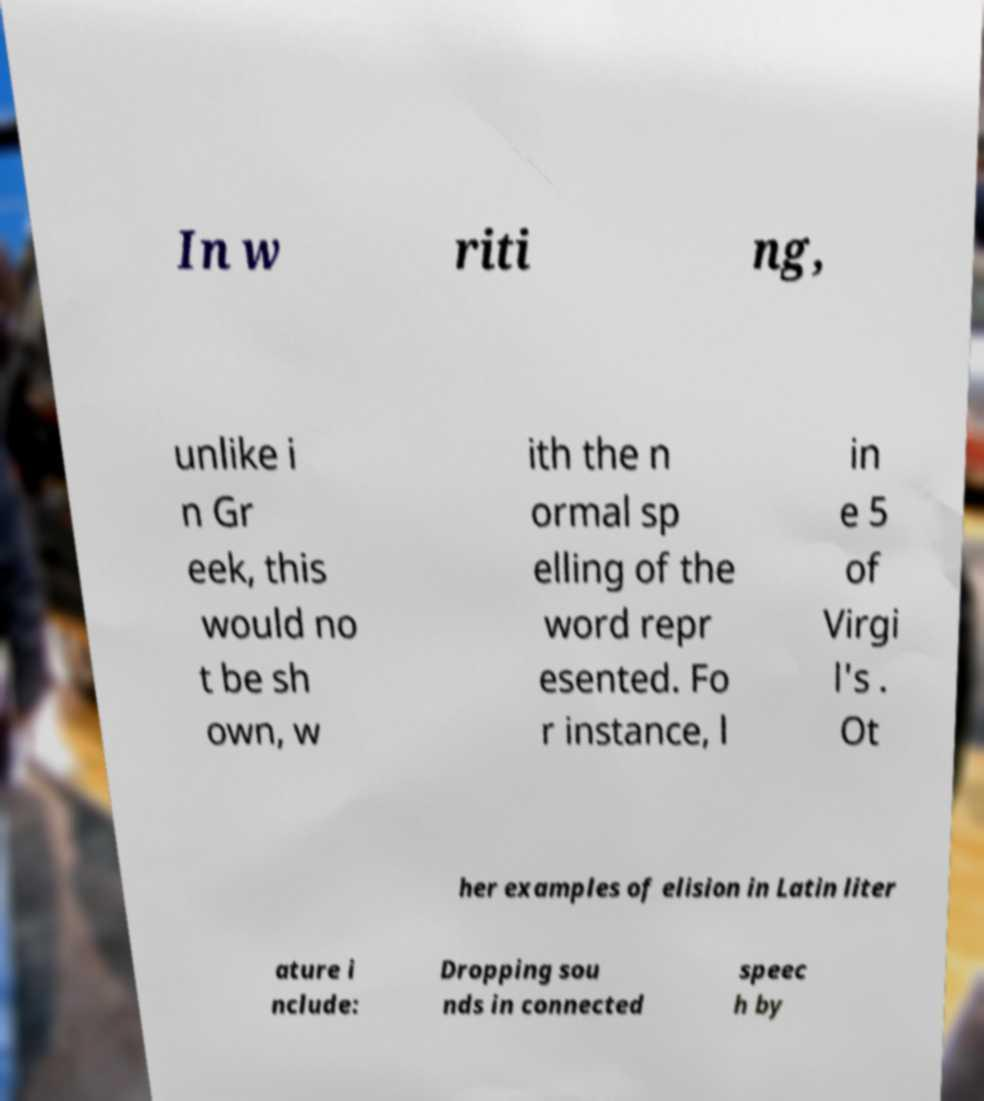For documentation purposes, I need the text within this image transcribed. Could you provide that? In w riti ng, unlike i n Gr eek, this would no t be sh own, w ith the n ormal sp elling of the word repr esented. Fo r instance, l in e 5 of Virgi l's . Ot her examples of elision in Latin liter ature i nclude: Dropping sou nds in connected speec h by 